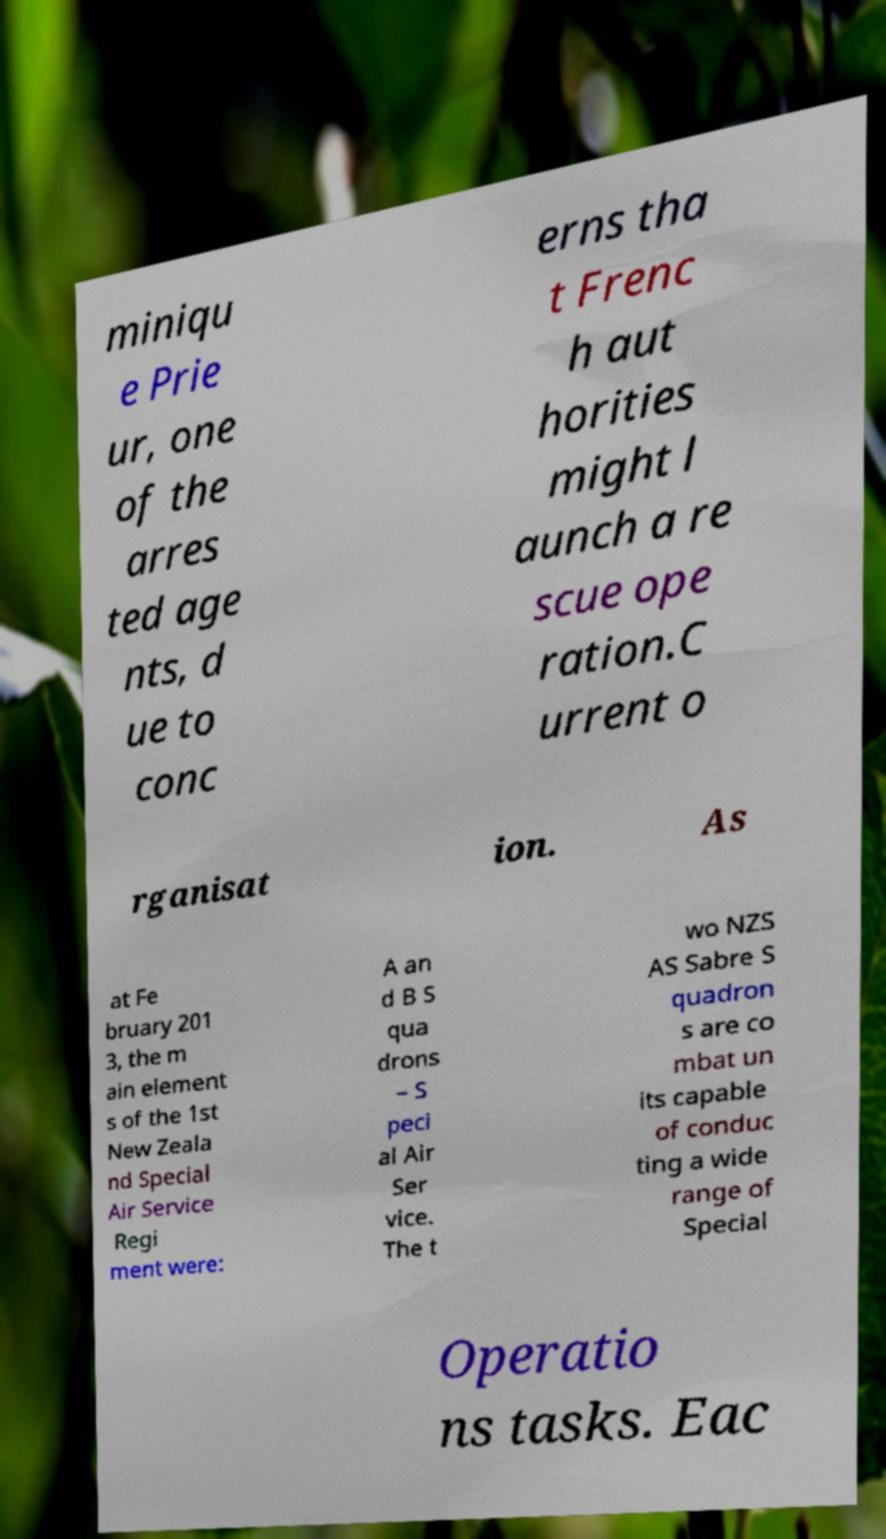For documentation purposes, I need the text within this image transcribed. Could you provide that? miniqu e Prie ur, one of the arres ted age nts, d ue to conc erns tha t Frenc h aut horities might l aunch a re scue ope ration.C urrent o rganisat ion. As at Fe bruary 201 3, the m ain element s of the 1st New Zeala nd Special Air Service Regi ment were: A an d B S qua drons – S peci al Air Ser vice. The t wo NZS AS Sabre S quadron s are co mbat un its capable of conduc ting a wide range of Special Operatio ns tasks. Eac 